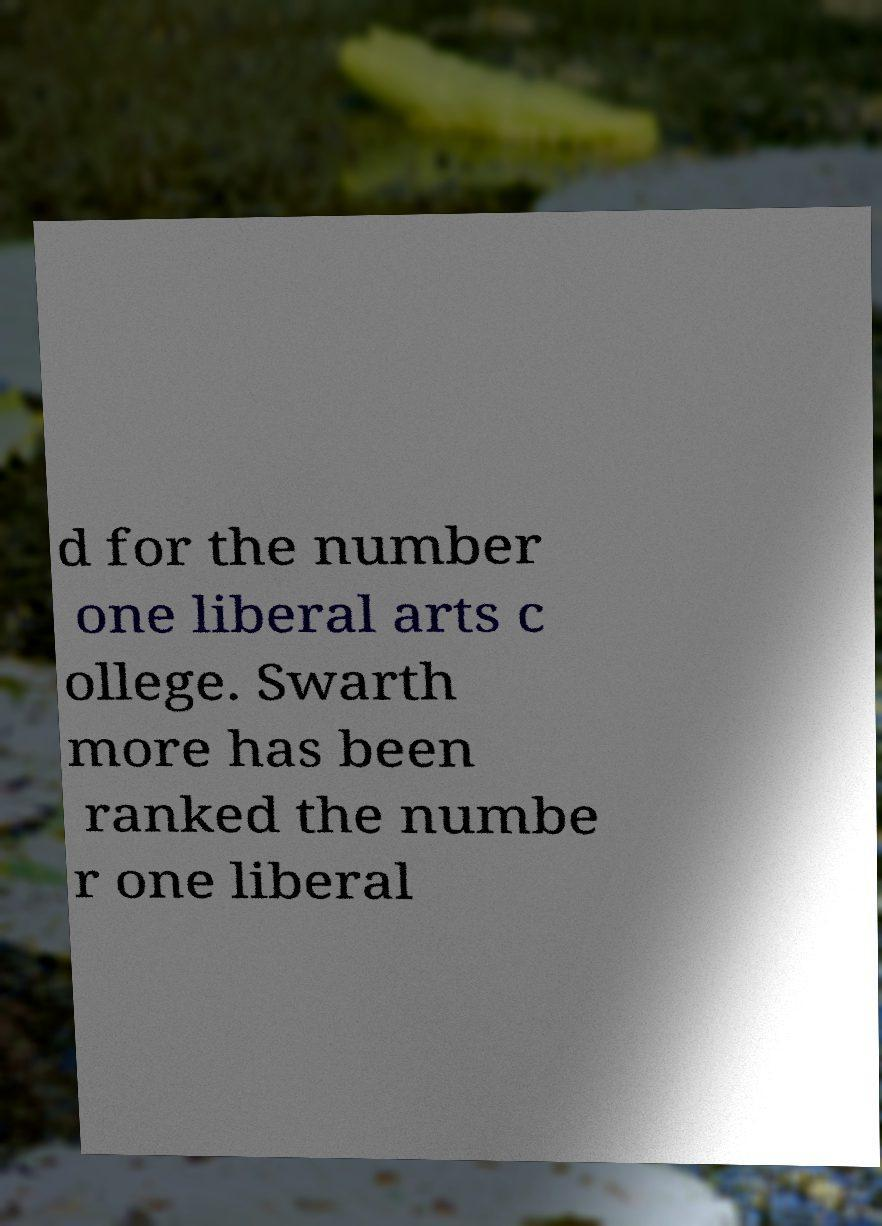I need the written content from this picture converted into text. Can you do that? d for the number one liberal arts c ollege. Swarth more has been ranked the numbe r one liberal 